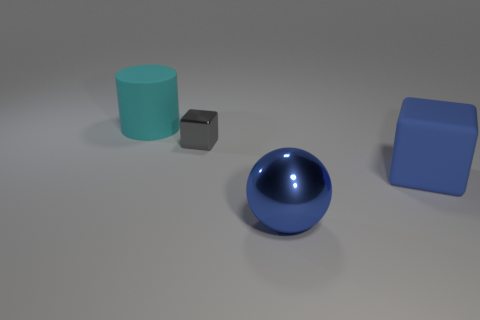What can you tell me about the lighting and shadows in this scene? The lighting in the scene appears to be coming from the upper right, casting shadows towards the lower left. Each object has a distinct shadow that corresponds to its shape. The shadow lengths suggest a light source that is not directly overhead but positioned at an angle. Does the lighting affect the color perception of the objects? Yes, lighting can significantly affect how we perceive the color of objects. In this case, the consistent light source helps to maintain the true colors of the objects, but areas in shadows might appear slightly darker or less saturated. 